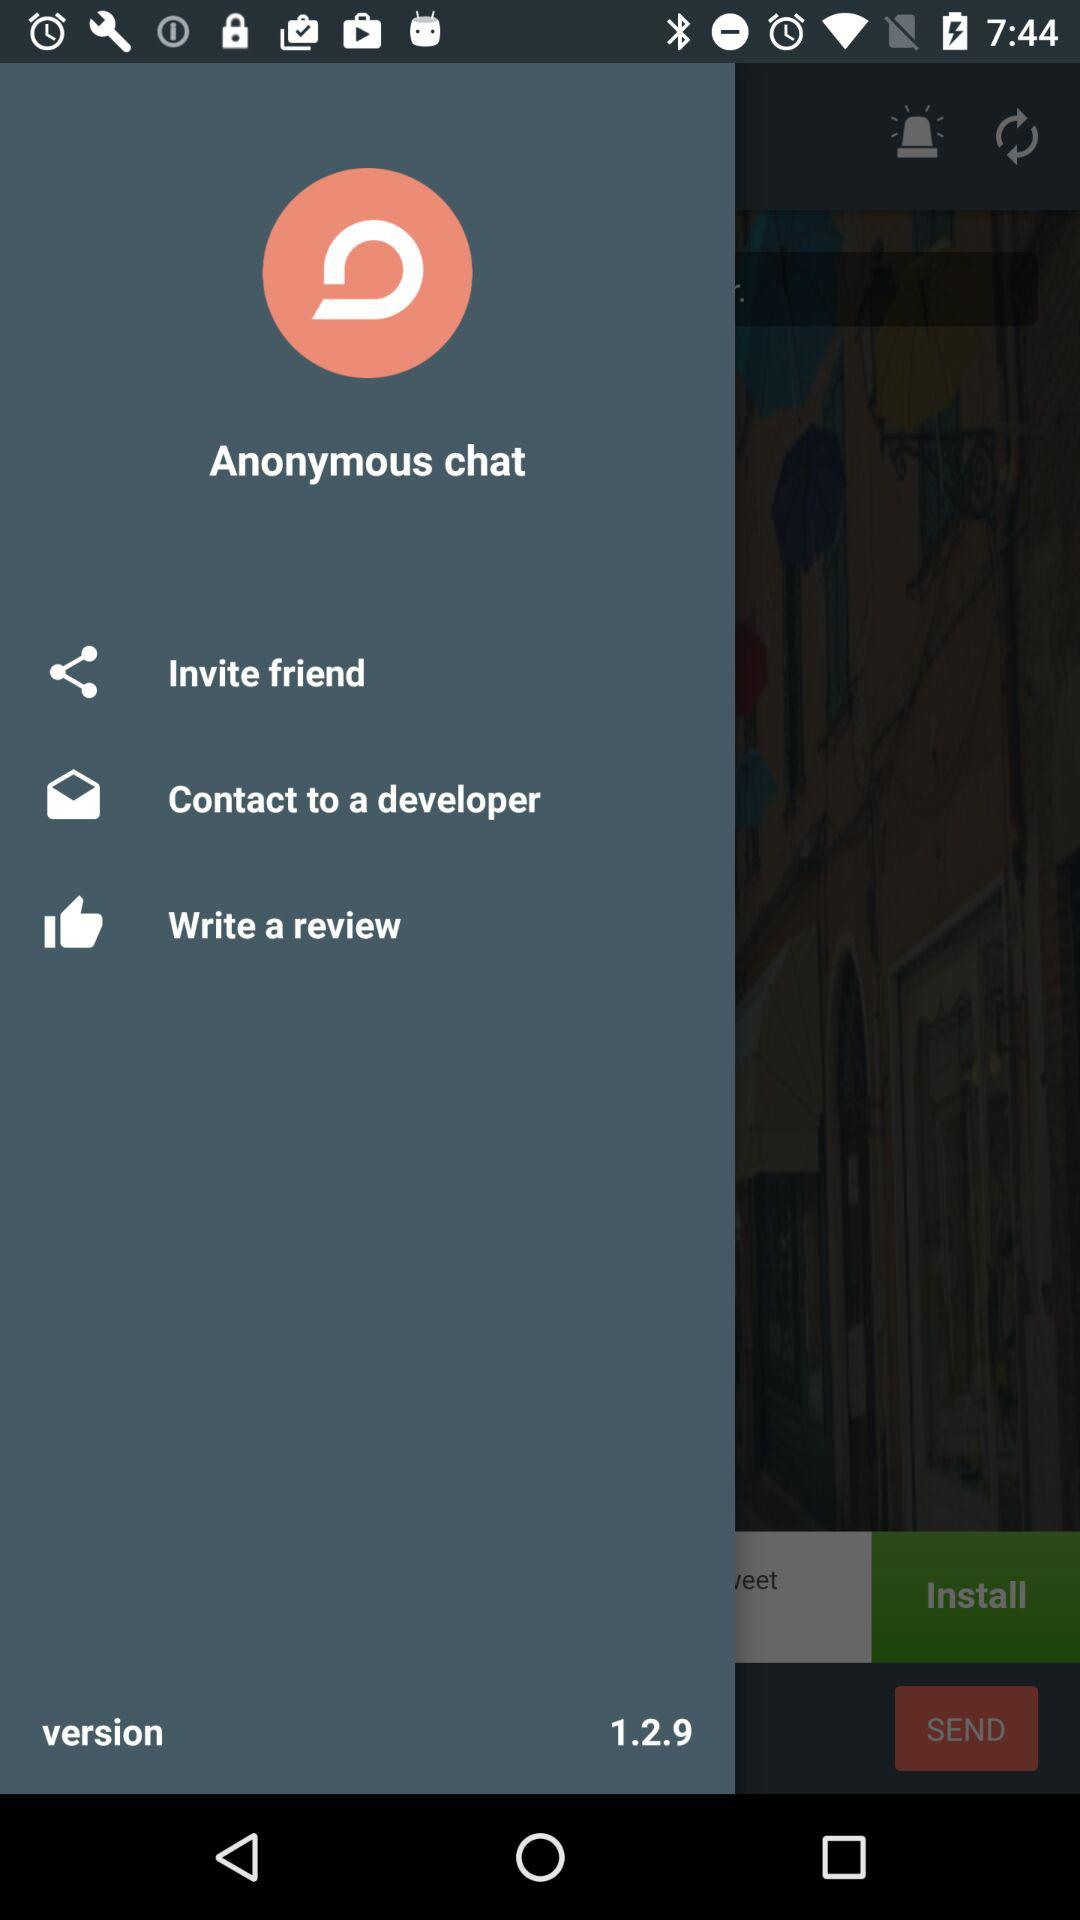What version of the application is this? The version is 1.2.9. 